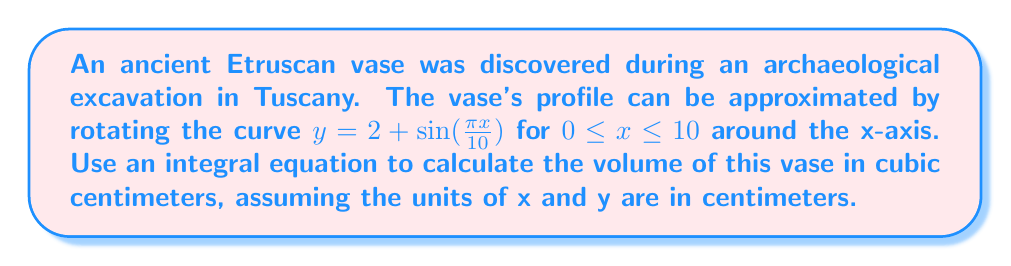Could you help me with this problem? To calculate the volume of a solid of revolution, we can use the washer method, which is derived from an integral equation. The steps are as follows:

1) The volume of a solid of revolution is given by the formula:

   $$V = \pi \int_{a}^{b} [R(x)^2 - r(x)^2] dx$$

   where $R(x)$ is the outer radius function and $r(x)$ is the inner radius function.

2) In this case, we're rotating around the x-axis, so $r(x) = 0$ and $R(x) = y = 2 + \sin(\frac{\pi x}{10})$.

3) Substituting these into our volume formula:

   $$V = \pi \int_{0}^{10} [2 + \sin(\frac{\pi x}{10})]^2 dx$$

4) Expand the squared term:

   $$V = \pi \int_{0}^{10} [4 + 4\sin(\frac{\pi x}{10}) + \sin^2(\frac{\pi x}{10})] dx$$

5) We can separate this into three integrals:

   $$V = \pi [\int_{0}^{10} 4 dx + \int_{0}^{10} 4\sin(\frac{\pi x}{10}) dx + \int_{0}^{10} \sin^2(\frac{\pi x}{10}) dx]$$

6) Solve each integral:
   - $\int_{0}^{10} 4 dx = 4x |_{0}^{10} = 40$
   - $\int_{0}^{10} 4\sin(\frac{\pi x}{10}) dx = -\frac{40}{\pi} \cos(\frac{\pi x}{10}) |_{0}^{10} = 0$
   - $\int_{0}^{10} \sin^2(\frac{\pi x}{10}) dx = \frac{10}{2} - \frac{5}{2\pi} \sin(\frac{\pi x}{5}) |_{0}^{10} = 5$

7) Sum the results and multiply by π:

   $$V = \pi (40 + 0 + 5) = 45\pi$$

Therefore, the volume of the Etruscan vase is $45\pi$ cubic centimeters.
Answer: $45\pi$ cm³ 